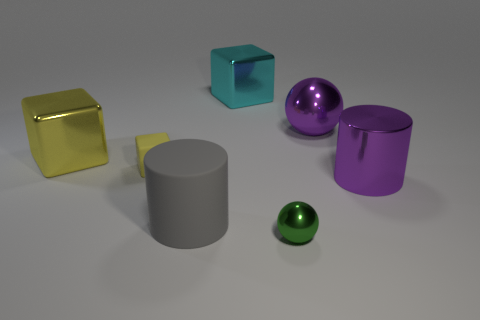Is the material of the sphere that is in front of the purple ball the same as the large gray cylinder?
Provide a short and direct response. No. How many other objects are the same material as the big gray thing?
Your answer should be compact. 1. What material is the thing that is the same size as the green shiny sphere?
Your answer should be very brief. Rubber. There is a purple metallic object behind the yellow matte block; is its shape the same as the metal thing in front of the gray object?
Ensure brevity in your answer.  Yes. What shape is the yellow object that is the same size as the cyan metal cube?
Ensure brevity in your answer.  Cube. Is the material of the big cube left of the rubber cylinder the same as the big cylinder that is to the right of the cyan metal cube?
Keep it short and to the point. Yes. There is a cube that is to the left of the tiny yellow thing; are there any small objects in front of it?
Provide a short and direct response. Yes. What is the color of the cylinder that is made of the same material as the purple sphere?
Make the answer very short. Purple. Is the number of large rubber cylinders greater than the number of brown metallic cylinders?
Your answer should be compact. Yes. How many things are large things behind the big yellow metallic block or gray matte cylinders?
Provide a succinct answer. 3. 